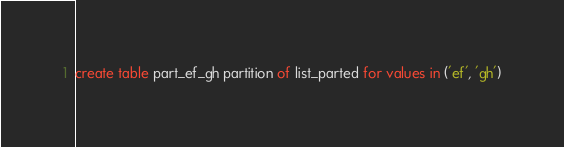Convert code to text. <code><loc_0><loc_0><loc_500><loc_500><_SQL_>create table part_ef_gh partition of list_parted for values in ('ef', 'gh')
</code> 